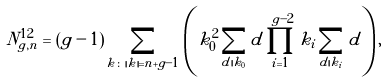<formula> <loc_0><loc_0><loc_500><loc_500>N _ { g , n } ^ { 1 2 } = \left ( g - 1 \right ) \sum _ { k \colon | k | = n + g - 1 } \left ( k _ { 0 } ^ { 2 } \sum _ { d | k _ { 0 } } d \prod _ { i = 1 } ^ { g - 2 } k _ { i } \sum _ { d | k _ { i } } d \right ) ,</formula> 